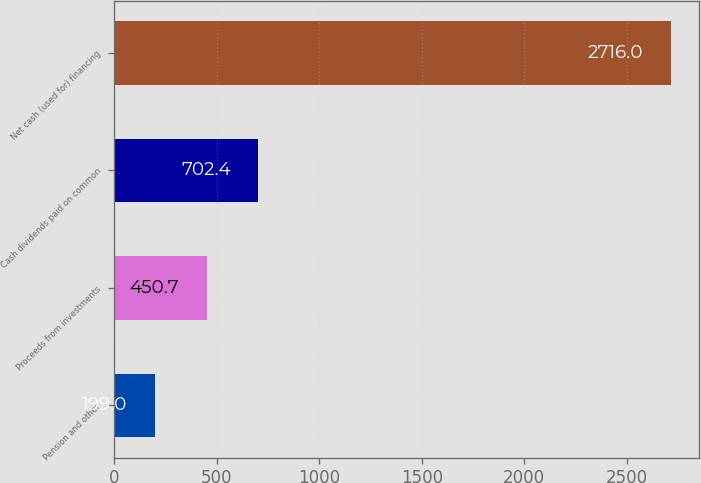Convert chart to OTSL. <chart><loc_0><loc_0><loc_500><loc_500><bar_chart><fcel>Pension and other<fcel>Proceeds from investments<fcel>Cash dividends paid on common<fcel>Net cash (used for) financing<nl><fcel>199<fcel>450.7<fcel>702.4<fcel>2716<nl></chart> 